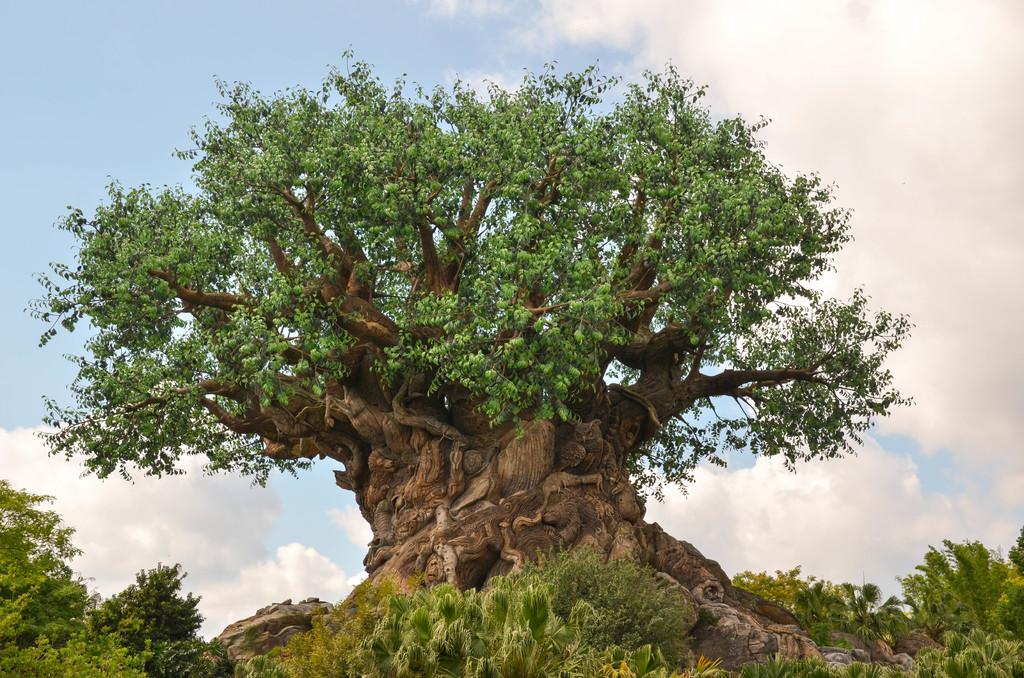What type of vegetation can be seen in the image? There are plants and trees in the image. What is visible in the background of the image? The sky is visible in the background of the image. What can be seen in the sky? Clouds are present in the sky. How many servants are standing next to the table in the image? There is no table or servant present in the image. Is there any snow visible in the image? There is no snow present in the image; it features plants, trees, and clouds in the sky. 